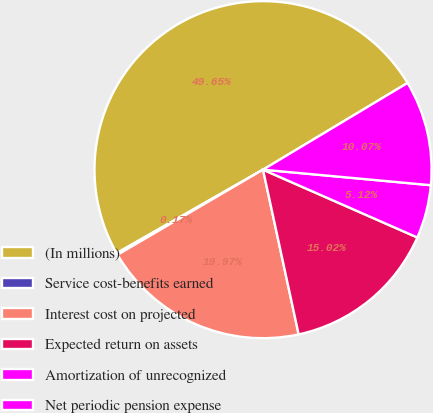<chart> <loc_0><loc_0><loc_500><loc_500><pie_chart><fcel>(In millions)<fcel>Service cost-benefits earned<fcel>Interest cost on projected<fcel>Expected return on assets<fcel>Amortization of unrecognized<fcel>Net periodic pension expense<nl><fcel>49.65%<fcel>0.17%<fcel>19.97%<fcel>15.02%<fcel>5.12%<fcel>10.07%<nl></chart> 